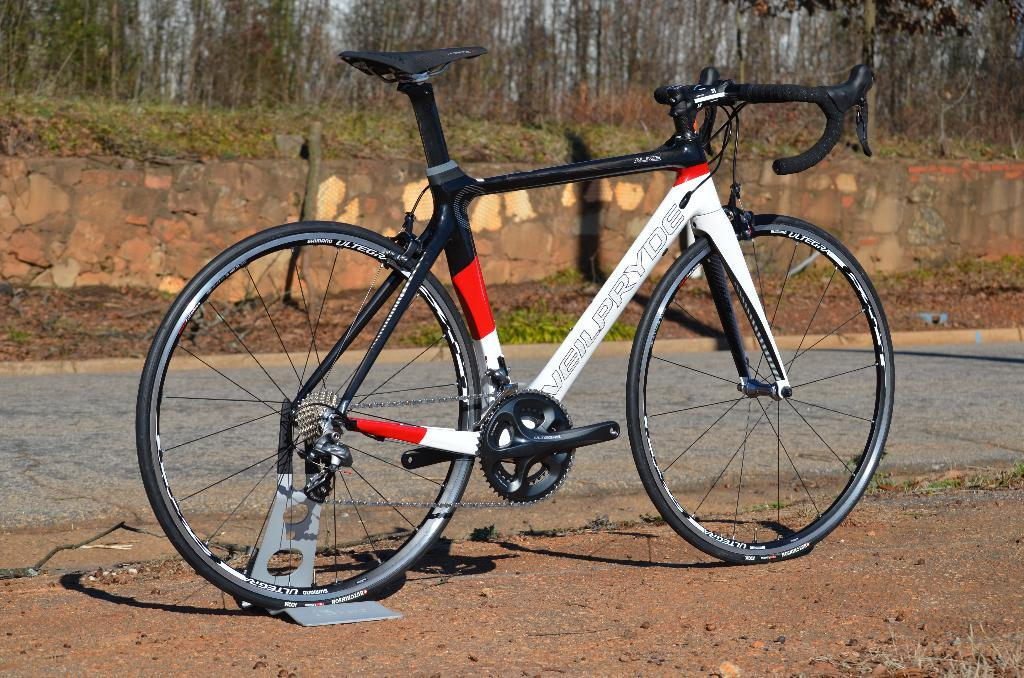What object is on the ground in the image? There is a bicycle on the ground in the image. What type of vegetation is present in the image? There are trees and grass in the image. What else can be found on the ground in the image? There are leaves on the ground in the image. What can be seen in the background of the image? There is a road and the sky visible in the image. Can you see any wounds on the trees in the image? There are no wounds visible on the trees in the image; they appear to be healthy. 